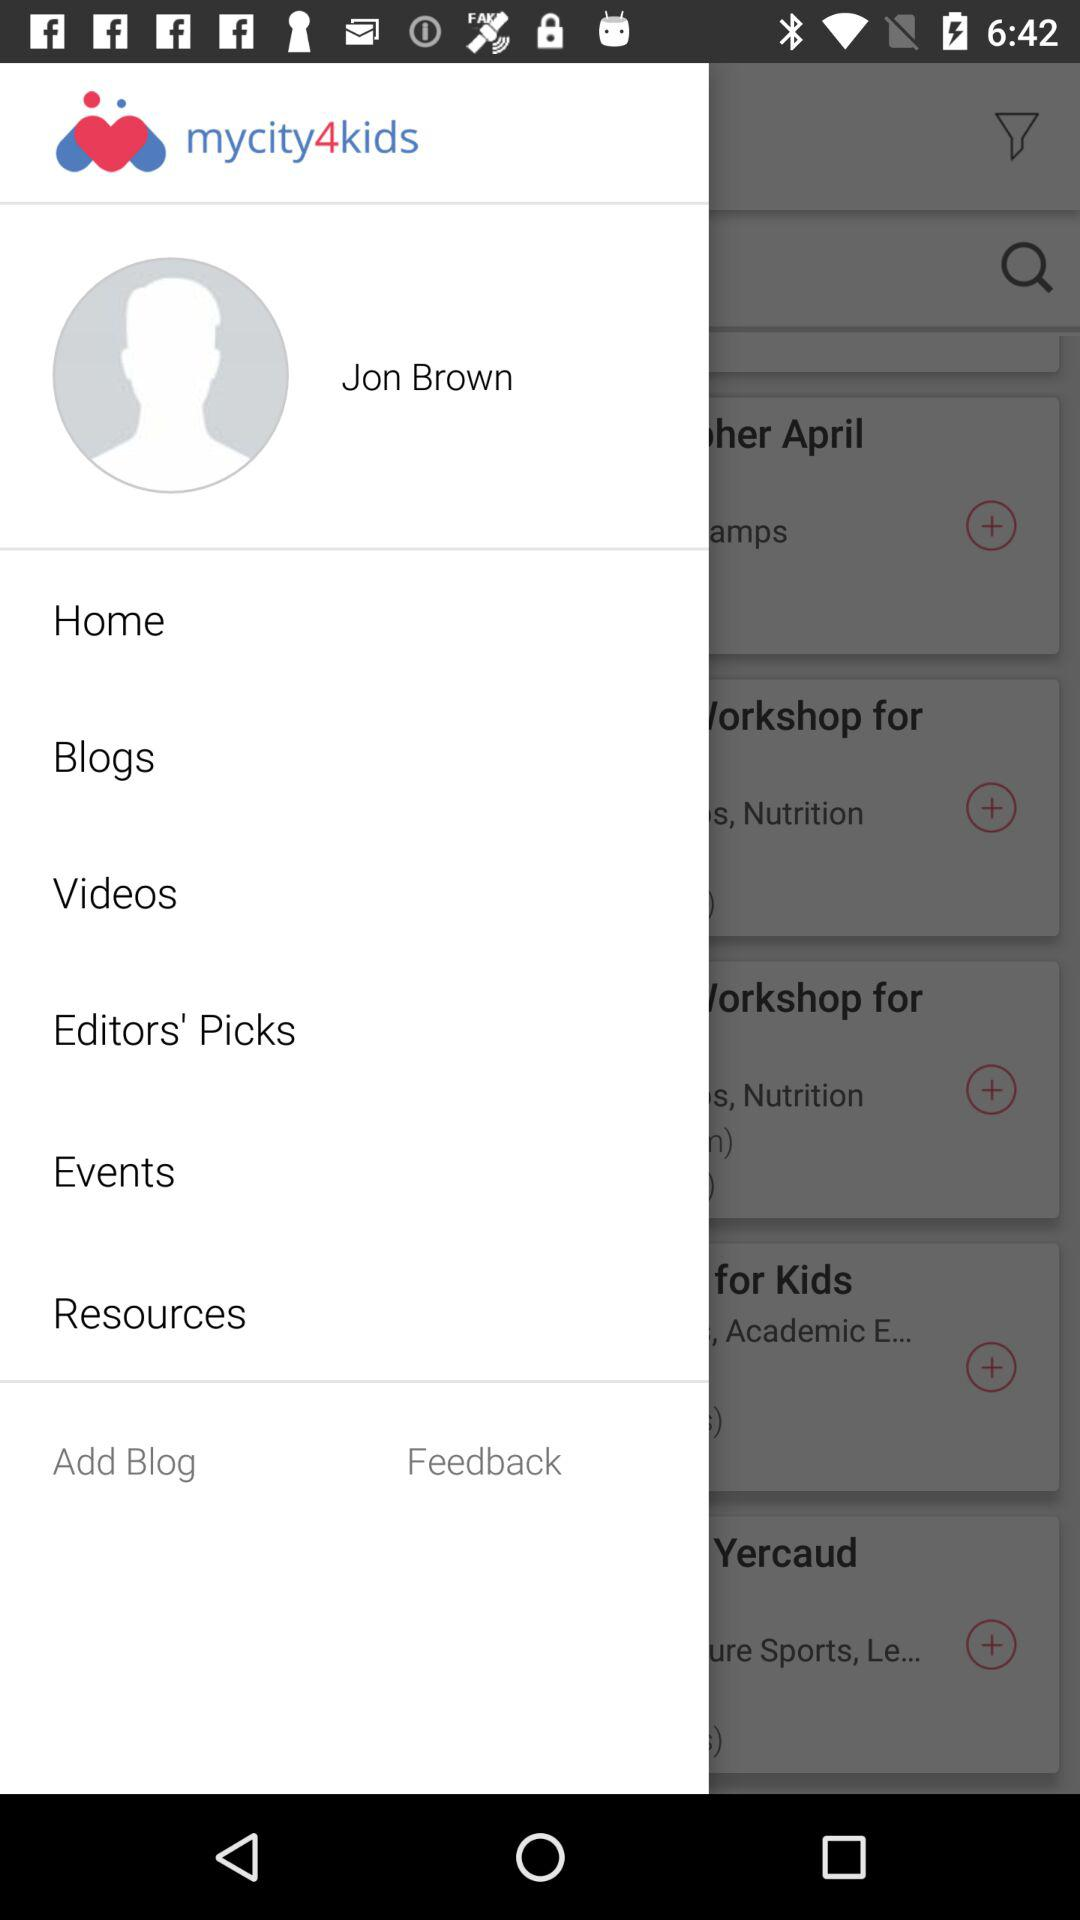What is the user name? The user name is Jon Brown. 